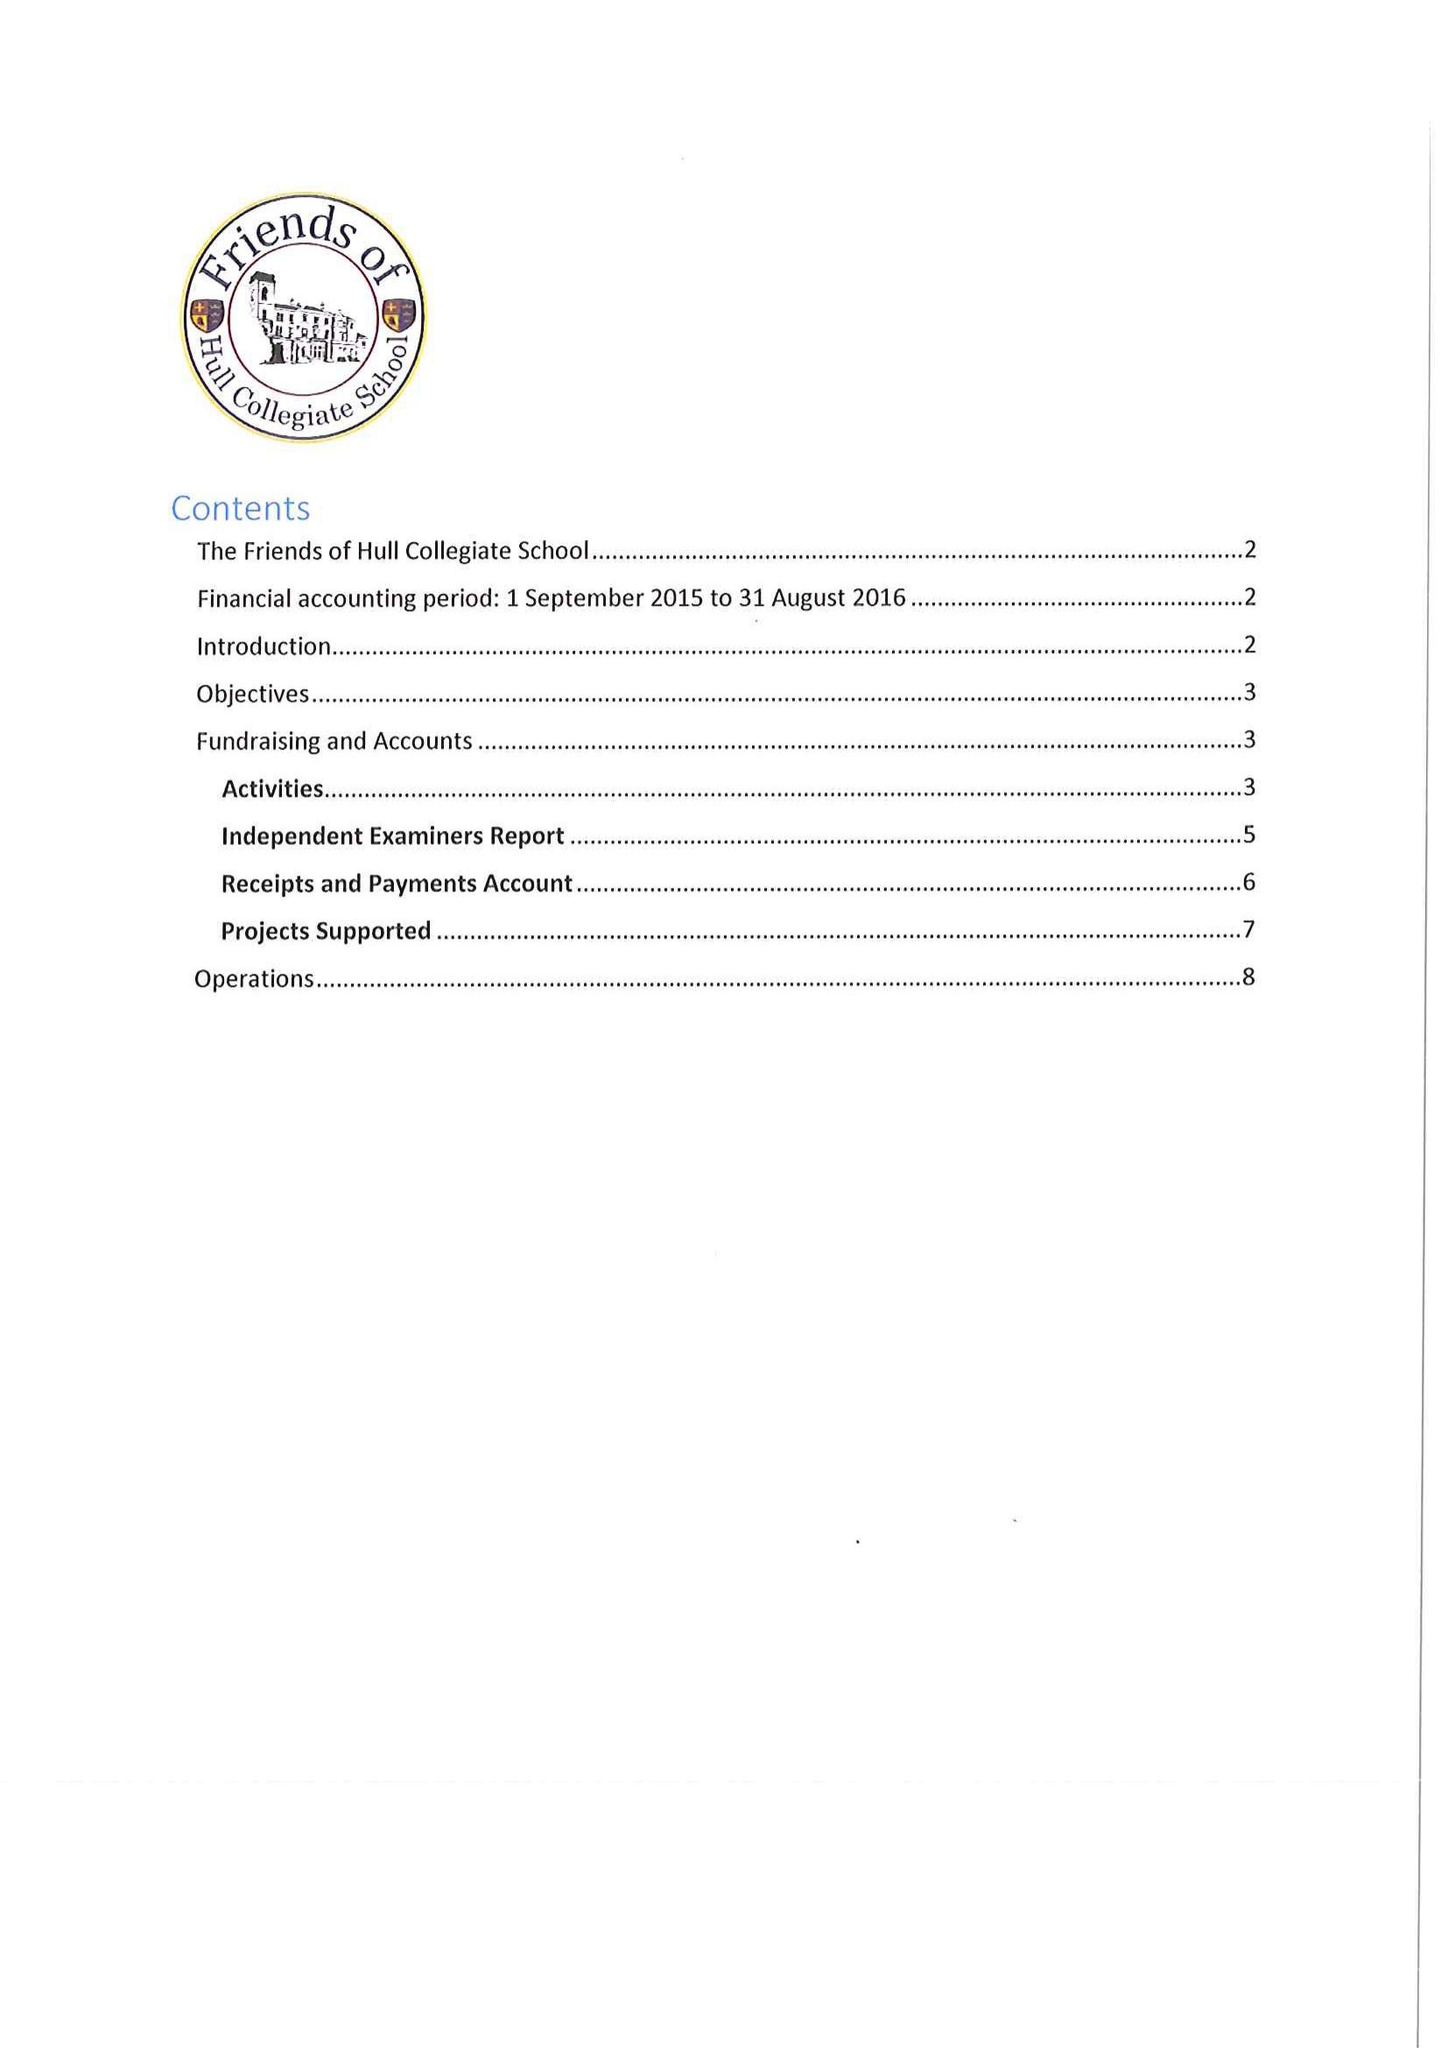What is the value for the spending_annually_in_british_pounds?
Answer the question using a single word or phrase. 28872.00 